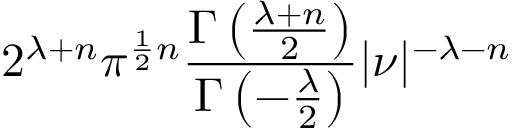Convert formula to latex. <formula><loc_0><loc_0><loc_500><loc_500>2 ^ { \lambda + n } \pi ^ { { \frac { 1 } { 2 } } n } { \frac { \Gamma \left ( { \frac { \lambda + n } { 2 } } \right ) } { \Gamma \left ( - { \frac { \lambda } { 2 } } \right ) } } | { \nu } | ^ { - \lambda - n }</formula> 